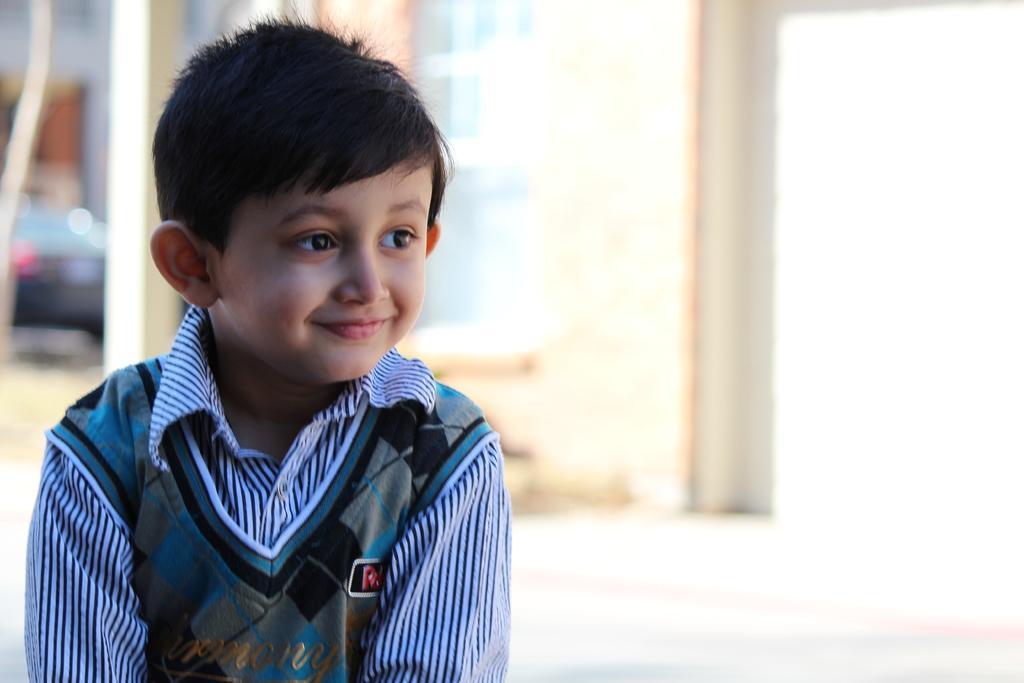Could you give a brief overview of what you see in this image? In this image, we can see a boy is smiling. Background there is a blur view. Left side of the image, we can see a vehicle. pillar. Here there is a wall. 